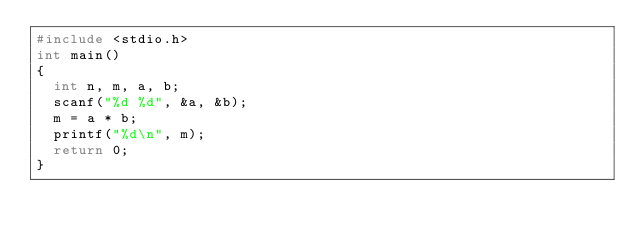Convert code to text. <code><loc_0><loc_0><loc_500><loc_500><_C_>#include <stdio.h>
int main()
{
	int n, m, a, b;
	scanf("%d %d", &a, &b);
	m = a * b;
	printf("%d\n", m);
	return 0;
}</code> 